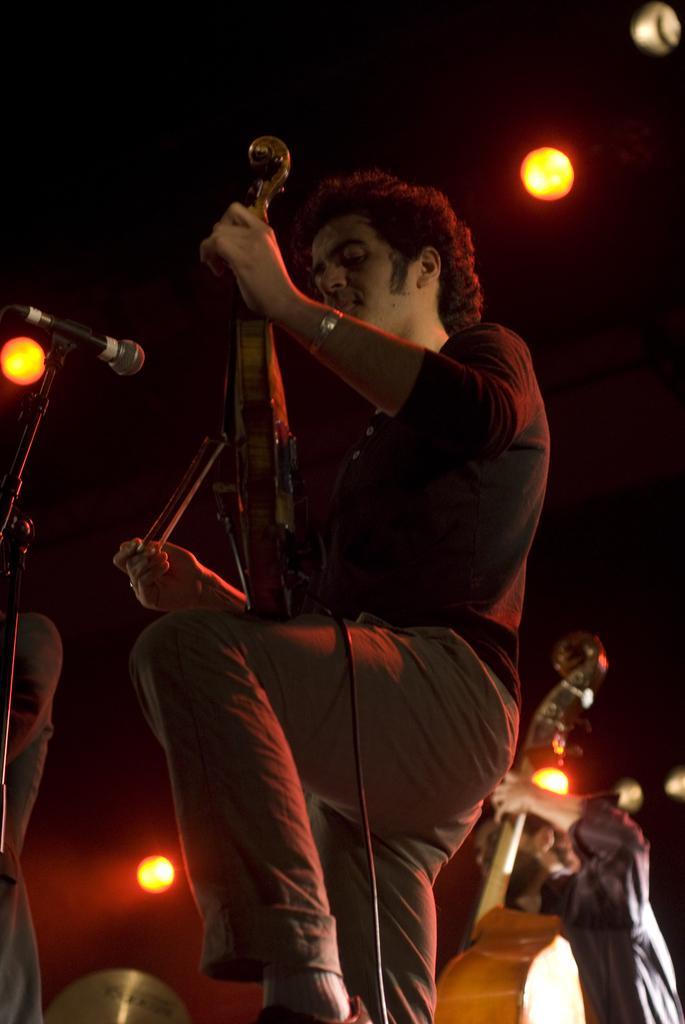Please provide a concise description of this image. In the image there is a man in black shirt and brown pants playing violin in front of mic and behind there is another man playing violin, there are lights over the ceiling. 